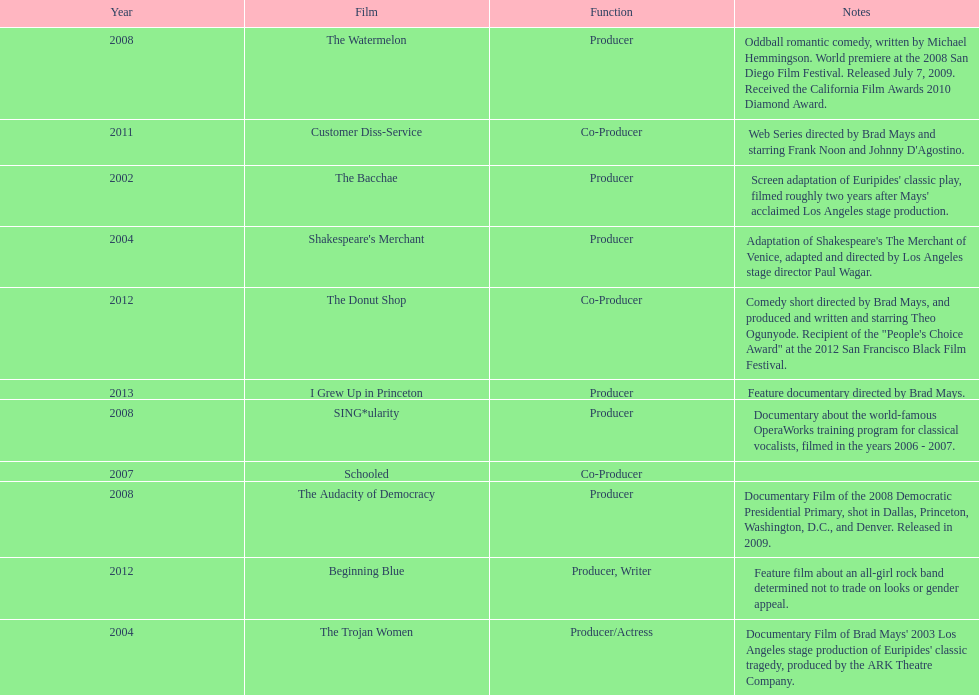How many films did ms. starfelt produce after 2010? 4. 